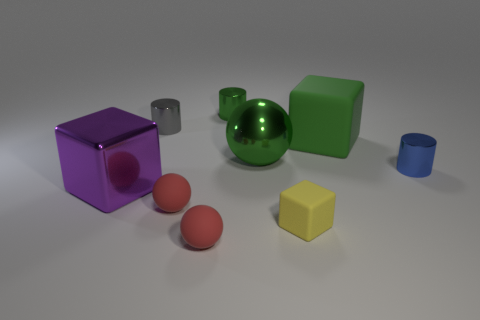Add 1 tiny red matte cylinders. How many objects exist? 10 Subtract all cylinders. How many objects are left? 6 Add 9 tiny blue metallic cylinders. How many tiny blue metallic cylinders are left? 10 Add 9 tiny green metal objects. How many tiny green metal objects exist? 10 Subtract 0 brown balls. How many objects are left? 9 Subtract all large purple metallic objects. Subtract all big cyan matte things. How many objects are left? 8 